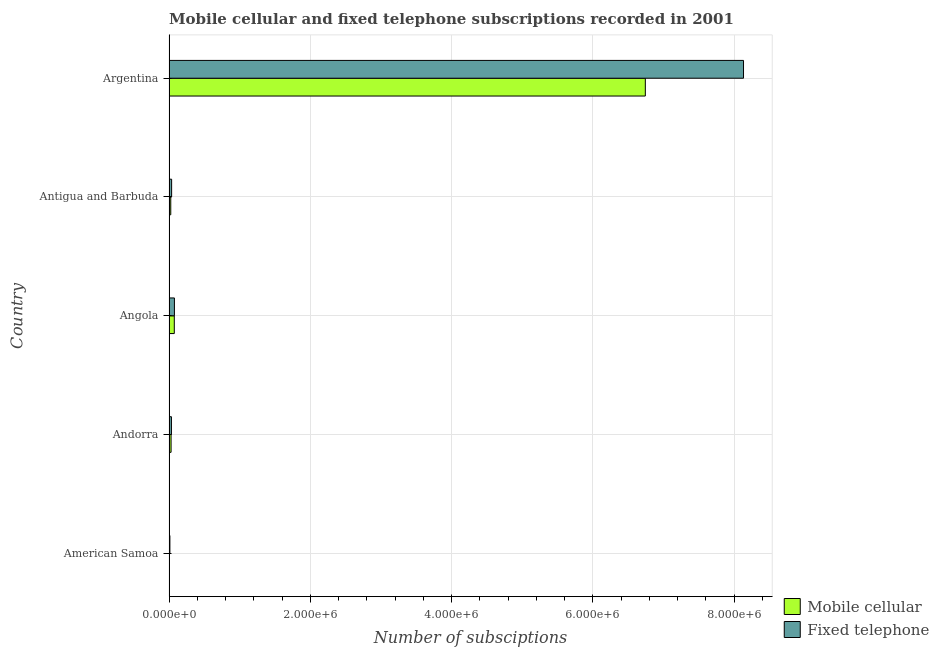Are the number of bars per tick equal to the number of legend labels?
Offer a terse response. Yes. Are the number of bars on each tick of the Y-axis equal?
Give a very brief answer. Yes. In how many cases, is the number of bars for a given country not equal to the number of legend labels?
Provide a short and direct response. 0. What is the number of fixed telephone subscriptions in American Samoa?
Provide a short and direct response. 1.26e+04. Across all countries, what is the maximum number of fixed telephone subscriptions?
Make the answer very short. 8.13e+06. Across all countries, what is the minimum number of fixed telephone subscriptions?
Keep it short and to the point. 1.26e+04. In which country was the number of fixed telephone subscriptions minimum?
Your answer should be compact. American Samoa. What is the total number of fixed telephone subscriptions in the graph?
Your answer should be very brief. 8.29e+06. What is the difference between the number of mobile cellular subscriptions in Andorra and that in Antigua and Barbuda?
Provide a succinct answer. 4429. What is the difference between the number of fixed telephone subscriptions in Andorra and the number of mobile cellular subscriptions in Antigua and Barbuda?
Provide a short and direct response. 9505. What is the average number of mobile cellular subscriptions per country?
Ensure brevity in your answer.  1.37e+06. What is the difference between the number of fixed telephone subscriptions and number of mobile cellular subscriptions in Andorra?
Your answer should be compact. 5076. What is the ratio of the number of mobile cellular subscriptions in American Samoa to that in Antigua and Barbuda?
Make the answer very short. 0.09. Is the difference between the number of fixed telephone subscriptions in American Samoa and Antigua and Barbuda greater than the difference between the number of mobile cellular subscriptions in American Samoa and Antigua and Barbuda?
Ensure brevity in your answer.  No. What is the difference between the highest and the second highest number of mobile cellular subscriptions?
Keep it short and to the point. 6.67e+06. What is the difference between the highest and the lowest number of fixed telephone subscriptions?
Offer a very short reply. 8.12e+06. Is the sum of the number of mobile cellular subscriptions in Antigua and Barbuda and Argentina greater than the maximum number of fixed telephone subscriptions across all countries?
Provide a succinct answer. No. What does the 2nd bar from the top in American Samoa represents?
Provide a succinct answer. Mobile cellular. What does the 1st bar from the bottom in Argentina represents?
Provide a succinct answer. Mobile cellular. How many bars are there?
Provide a succinct answer. 10. Are all the bars in the graph horizontal?
Provide a succinct answer. Yes. How many countries are there in the graph?
Offer a very short reply. 5. What is the difference between two consecutive major ticks on the X-axis?
Your answer should be compact. 2.00e+06. Are the values on the major ticks of X-axis written in scientific E-notation?
Make the answer very short. Yes. Where does the legend appear in the graph?
Offer a terse response. Bottom right. What is the title of the graph?
Your answer should be compact. Mobile cellular and fixed telephone subscriptions recorded in 2001. Does "Taxes on profits and capital gains" appear as one of the legend labels in the graph?
Keep it short and to the point. No. What is the label or title of the X-axis?
Offer a very short reply. Number of subsciptions. What is the label or title of the Y-axis?
Make the answer very short. Country. What is the Number of subsciptions in Mobile cellular in American Samoa?
Make the answer very short. 2156. What is the Number of subsciptions in Fixed telephone in American Samoa?
Offer a terse response. 1.26e+04. What is the Number of subsciptions in Mobile cellular in Andorra?
Your answer should be very brief. 2.94e+04. What is the Number of subsciptions in Fixed telephone in Andorra?
Make the answer very short. 3.45e+04. What is the Number of subsciptions in Mobile cellular in Angola?
Your answer should be very brief. 7.50e+04. What is the Number of subsciptions in Fixed telephone in Angola?
Give a very brief answer. 7.68e+04. What is the Number of subsciptions in Mobile cellular in Antigua and Barbuda?
Your response must be concise. 2.50e+04. What is the Number of subsciptions in Fixed telephone in Antigua and Barbuda?
Give a very brief answer. 3.73e+04. What is the Number of subsciptions in Mobile cellular in Argentina?
Ensure brevity in your answer.  6.74e+06. What is the Number of subsciptions of Fixed telephone in Argentina?
Make the answer very short. 8.13e+06. Across all countries, what is the maximum Number of subsciptions in Mobile cellular?
Your answer should be very brief. 6.74e+06. Across all countries, what is the maximum Number of subsciptions in Fixed telephone?
Provide a succinct answer. 8.13e+06. Across all countries, what is the minimum Number of subsciptions of Mobile cellular?
Your response must be concise. 2156. Across all countries, what is the minimum Number of subsciptions in Fixed telephone?
Ensure brevity in your answer.  1.26e+04. What is the total Number of subsciptions of Mobile cellular in the graph?
Provide a succinct answer. 6.87e+06. What is the total Number of subsciptions of Fixed telephone in the graph?
Your answer should be compact. 8.29e+06. What is the difference between the Number of subsciptions in Mobile cellular in American Samoa and that in Andorra?
Make the answer very short. -2.73e+04. What is the difference between the Number of subsciptions in Fixed telephone in American Samoa and that in Andorra?
Give a very brief answer. -2.19e+04. What is the difference between the Number of subsciptions of Mobile cellular in American Samoa and that in Angola?
Offer a very short reply. -7.28e+04. What is the difference between the Number of subsciptions of Fixed telephone in American Samoa and that in Angola?
Ensure brevity in your answer.  -6.42e+04. What is the difference between the Number of subsciptions in Mobile cellular in American Samoa and that in Antigua and Barbuda?
Ensure brevity in your answer.  -2.28e+04. What is the difference between the Number of subsciptions of Fixed telephone in American Samoa and that in Antigua and Barbuda?
Ensure brevity in your answer.  -2.47e+04. What is the difference between the Number of subsciptions in Mobile cellular in American Samoa and that in Argentina?
Make the answer very short. -6.74e+06. What is the difference between the Number of subsciptions in Fixed telephone in American Samoa and that in Argentina?
Ensure brevity in your answer.  -8.12e+06. What is the difference between the Number of subsciptions in Mobile cellular in Andorra and that in Angola?
Your answer should be compact. -4.56e+04. What is the difference between the Number of subsciptions of Fixed telephone in Andorra and that in Angola?
Your answer should be very brief. -4.23e+04. What is the difference between the Number of subsciptions of Mobile cellular in Andorra and that in Antigua and Barbuda?
Your response must be concise. 4429. What is the difference between the Number of subsciptions in Fixed telephone in Andorra and that in Antigua and Barbuda?
Give a very brief answer. -2759. What is the difference between the Number of subsciptions of Mobile cellular in Andorra and that in Argentina?
Your answer should be compact. -6.71e+06. What is the difference between the Number of subsciptions in Fixed telephone in Andorra and that in Argentina?
Make the answer very short. -8.10e+06. What is the difference between the Number of subsciptions in Mobile cellular in Angola and that in Antigua and Barbuda?
Offer a terse response. 5.00e+04. What is the difference between the Number of subsciptions of Fixed telephone in Angola and that in Antigua and Barbuda?
Give a very brief answer. 3.95e+04. What is the difference between the Number of subsciptions in Mobile cellular in Angola and that in Argentina?
Keep it short and to the point. -6.67e+06. What is the difference between the Number of subsciptions of Fixed telephone in Angola and that in Argentina?
Offer a very short reply. -8.05e+06. What is the difference between the Number of subsciptions in Mobile cellular in Antigua and Barbuda and that in Argentina?
Offer a terse response. -6.72e+06. What is the difference between the Number of subsciptions of Fixed telephone in Antigua and Barbuda and that in Argentina?
Provide a succinct answer. -8.09e+06. What is the difference between the Number of subsciptions in Mobile cellular in American Samoa and the Number of subsciptions in Fixed telephone in Andorra?
Keep it short and to the point. -3.23e+04. What is the difference between the Number of subsciptions in Mobile cellular in American Samoa and the Number of subsciptions in Fixed telephone in Angola?
Make the answer very short. -7.46e+04. What is the difference between the Number of subsciptions of Mobile cellular in American Samoa and the Number of subsciptions of Fixed telephone in Antigua and Barbuda?
Your response must be concise. -3.51e+04. What is the difference between the Number of subsciptions in Mobile cellular in American Samoa and the Number of subsciptions in Fixed telephone in Argentina?
Your answer should be very brief. -8.13e+06. What is the difference between the Number of subsciptions of Mobile cellular in Andorra and the Number of subsciptions of Fixed telephone in Angola?
Your answer should be compact. -4.74e+04. What is the difference between the Number of subsciptions in Mobile cellular in Andorra and the Number of subsciptions in Fixed telephone in Antigua and Barbuda?
Ensure brevity in your answer.  -7835. What is the difference between the Number of subsciptions of Mobile cellular in Andorra and the Number of subsciptions of Fixed telephone in Argentina?
Make the answer very short. -8.10e+06. What is the difference between the Number of subsciptions in Mobile cellular in Angola and the Number of subsciptions in Fixed telephone in Antigua and Barbuda?
Your answer should be very brief. 3.77e+04. What is the difference between the Number of subsciptions of Mobile cellular in Angola and the Number of subsciptions of Fixed telephone in Argentina?
Your answer should be very brief. -8.06e+06. What is the difference between the Number of subsciptions of Mobile cellular in Antigua and Barbuda and the Number of subsciptions of Fixed telephone in Argentina?
Your answer should be compact. -8.11e+06. What is the average Number of subsciptions of Mobile cellular per country?
Give a very brief answer. 1.37e+06. What is the average Number of subsciptions in Fixed telephone per country?
Offer a very short reply. 1.66e+06. What is the difference between the Number of subsciptions of Mobile cellular and Number of subsciptions of Fixed telephone in American Samoa?
Give a very brief answer. -1.04e+04. What is the difference between the Number of subsciptions in Mobile cellular and Number of subsciptions in Fixed telephone in Andorra?
Keep it short and to the point. -5076. What is the difference between the Number of subsciptions in Mobile cellular and Number of subsciptions in Fixed telephone in Angola?
Provide a succinct answer. -1800. What is the difference between the Number of subsciptions of Mobile cellular and Number of subsciptions of Fixed telephone in Antigua and Barbuda?
Make the answer very short. -1.23e+04. What is the difference between the Number of subsciptions in Mobile cellular and Number of subsciptions in Fixed telephone in Argentina?
Your answer should be compact. -1.39e+06. What is the ratio of the Number of subsciptions in Mobile cellular in American Samoa to that in Andorra?
Give a very brief answer. 0.07. What is the ratio of the Number of subsciptions in Fixed telephone in American Samoa to that in Andorra?
Provide a short and direct response. 0.36. What is the ratio of the Number of subsciptions in Mobile cellular in American Samoa to that in Angola?
Your answer should be compact. 0.03. What is the ratio of the Number of subsciptions of Fixed telephone in American Samoa to that in Angola?
Offer a terse response. 0.16. What is the ratio of the Number of subsciptions in Mobile cellular in American Samoa to that in Antigua and Barbuda?
Provide a succinct answer. 0.09. What is the ratio of the Number of subsciptions in Fixed telephone in American Samoa to that in Antigua and Barbuda?
Give a very brief answer. 0.34. What is the ratio of the Number of subsciptions in Mobile cellular in American Samoa to that in Argentina?
Give a very brief answer. 0. What is the ratio of the Number of subsciptions of Fixed telephone in American Samoa to that in Argentina?
Keep it short and to the point. 0. What is the ratio of the Number of subsciptions of Mobile cellular in Andorra to that in Angola?
Give a very brief answer. 0.39. What is the ratio of the Number of subsciptions in Fixed telephone in Andorra to that in Angola?
Give a very brief answer. 0.45. What is the ratio of the Number of subsciptions in Mobile cellular in Andorra to that in Antigua and Barbuda?
Offer a terse response. 1.18. What is the ratio of the Number of subsciptions in Fixed telephone in Andorra to that in Antigua and Barbuda?
Provide a short and direct response. 0.93. What is the ratio of the Number of subsciptions of Mobile cellular in Andorra to that in Argentina?
Your answer should be very brief. 0. What is the ratio of the Number of subsciptions of Fixed telephone in Andorra to that in Argentina?
Provide a succinct answer. 0. What is the ratio of the Number of subsciptions of Fixed telephone in Angola to that in Antigua and Barbuda?
Offer a very short reply. 2.06. What is the ratio of the Number of subsciptions of Mobile cellular in Angola to that in Argentina?
Provide a succinct answer. 0.01. What is the ratio of the Number of subsciptions in Fixed telephone in Angola to that in Argentina?
Give a very brief answer. 0.01. What is the ratio of the Number of subsciptions in Mobile cellular in Antigua and Barbuda to that in Argentina?
Ensure brevity in your answer.  0. What is the ratio of the Number of subsciptions in Fixed telephone in Antigua and Barbuda to that in Argentina?
Offer a terse response. 0. What is the difference between the highest and the second highest Number of subsciptions of Mobile cellular?
Offer a terse response. 6.67e+06. What is the difference between the highest and the second highest Number of subsciptions of Fixed telephone?
Keep it short and to the point. 8.05e+06. What is the difference between the highest and the lowest Number of subsciptions of Mobile cellular?
Your response must be concise. 6.74e+06. What is the difference between the highest and the lowest Number of subsciptions in Fixed telephone?
Provide a succinct answer. 8.12e+06. 